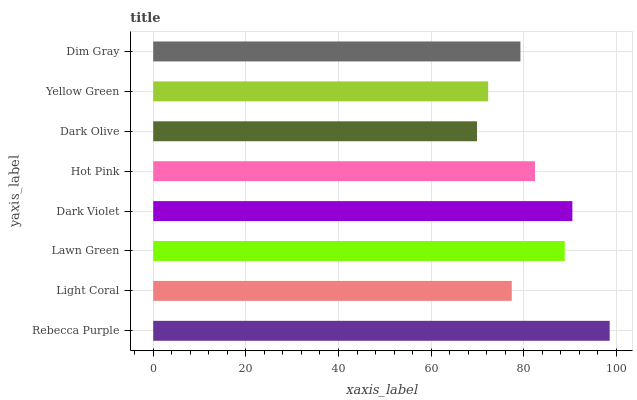Is Dark Olive the minimum?
Answer yes or no. Yes. Is Rebecca Purple the maximum?
Answer yes or no. Yes. Is Light Coral the minimum?
Answer yes or no. No. Is Light Coral the maximum?
Answer yes or no. No. Is Rebecca Purple greater than Light Coral?
Answer yes or no. Yes. Is Light Coral less than Rebecca Purple?
Answer yes or no. Yes. Is Light Coral greater than Rebecca Purple?
Answer yes or no. No. Is Rebecca Purple less than Light Coral?
Answer yes or no. No. Is Hot Pink the high median?
Answer yes or no. Yes. Is Dim Gray the low median?
Answer yes or no. Yes. Is Dim Gray the high median?
Answer yes or no. No. Is Light Coral the low median?
Answer yes or no. No. 